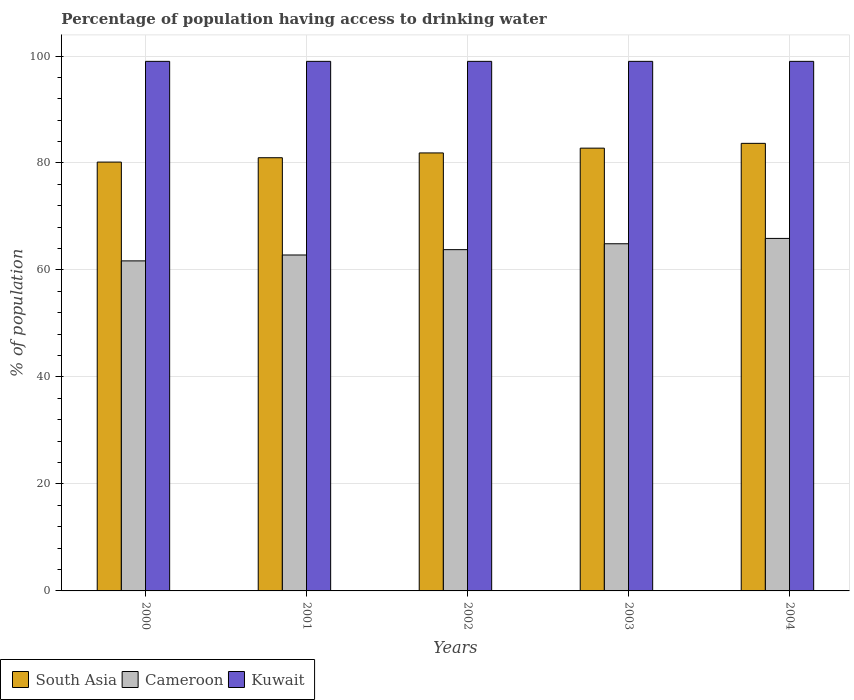How many different coloured bars are there?
Your answer should be compact. 3. Are the number of bars per tick equal to the number of legend labels?
Make the answer very short. Yes. How many bars are there on the 2nd tick from the left?
Your response must be concise. 3. How many bars are there on the 5th tick from the right?
Your response must be concise. 3. What is the percentage of population having access to drinking water in Kuwait in 2003?
Keep it short and to the point. 99. Across all years, what is the maximum percentage of population having access to drinking water in Cameroon?
Your answer should be very brief. 65.9. Across all years, what is the minimum percentage of population having access to drinking water in Kuwait?
Make the answer very short. 99. What is the total percentage of population having access to drinking water in South Asia in the graph?
Give a very brief answer. 409.48. What is the difference between the percentage of population having access to drinking water in Cameroon in 2000 and the percentage of population having access to drinking water in South Asia in 2003?
Give a very brief answer. -21.07. What is the average percentage of population having access to drinking water in Cameroon per year?
Offer a terse response. 63.82. In the year 2004, what is the difference between the percentage of population having access to drinking water in Kuwait and percentage of population having access to drinking water in South Asia?
Offer a very short reply. 15.33. What is the ratio of the percentage of population having access to drinking water in South Asia in 2002 to that in 2003?
Provide a succinct answer. 0.99. Is the percentage of population having access to drinking water in Cameroon in 2000 less than that in 2001?
Your answer should be compact. Yes. What is the difference between the highest and the second highest percentage of population having access to drinking water in Cameroon?
Give a very brief answer. 1. What is the difference between the highest and the lowest percentage of population having access to drinking water in Cameroon?
Offer a very short reply. 4.2. In how many years, is the percentage of population having access to drinking water in Kuwait greater than the average percentage of population having access to drinking water in Kuwait taken over all years?
Offer a terse response. 0. What does the 2nd bar from the left in 2003 represents?
Provide a short and direct response. Cameroon. What does the 1st bar from the right in 2003 represents?
Your answer should be very brief. Kuwait. What is the difference between two consecutive major ticks on the Y-axis?
Provide a succinct answer. 20. Are the values on the major ticks of Y-axis written in scientific E-notation?
Provide a succinct answer. No. Does the graph contain grids?
Provide a short and direct response. Yes. Where does the legend appear in the graph?
Offer a terse response. Bottom left. How are the legend labels stacked?
Ensure brevity in your answer.  Horizontal. What is the title of the graph?
Make the answer very short. Percentage of population having access to drinking water. Does "Sao Tome and Principe" appear as one of the legend labels in the graph?
Ensure brevity in your answer.  No. What is the label or title of the Y-axis?
Provide a succinct answer. % of population. What is the % of population in South Asia in 2000?
Give a very brief answer. 80.17. What is the % of population of Cameroon in 2000?
Provide a succinct answer. 61.7. What is the % of population of Kuwait in 2000?
Provide a succinct answer. 99. What is the % of population in South Asia in 2001?
Provide a short and direct response. 80.98. What is the % of population of Cameroon in 2001?
Make the answer very short. 62.8. What is the % of population in South Asia in 2002?
Give a very brief answer. 81.88. What is the % of population in Cameroon in 2002?
Make the answer very short. 63.8. What is the % of population of South Asia in 2003?
Provide a short and direct response. 82.77. What is the % of population of Cameroon in 2003?
Provide a short and direct response. 64.9. What is the % of population of South Asia in 2004?
Ensure brevity in your answer.  83.67. What is the % of population in Cameroon in 2004?
Your response must be concise. 65.9. Across all years, what is the maximum % of population in South Asia?
Make the answer very short. 83.67. Across all years, what is the maximum % of population in Cameroon?
Make the answer very short. 65.9. Across all years, what is the maximum % of population of Kuwait?
Ensure brevity in your answer.  99. Across all years, what is the minimum % of population in South Asia?
Your answer should be very brief. 80.17. Across all years, what is the minimum % of population in Cameroon?
Your answer should be compact. 61.7. Across all years, what is the minimum % of population in Kuwait?
Your answer should be compact. 99. What is the total % of population of South Asia in the graph?
Your answer should be very brief. 409.48. What is the total % of population of Cameroon in the graph?
Offer a terse response. 319.1. What is the total % of population of Kuwait in the graph?
Make the answer very short. 495. What is the difference between the % of population in South Asia in 2000 and that in 2001?
Provide a succinct answer. -0.81. What is the difference between the % of population in Kuwait in 2000 and that in 2001?
Give a very brief answer. 0. What is the difference between the % of population of South Asia in 2000 and that in 2002?
Your answer should be compact. -1.71. What is the difference between the % of population of Cameroon in 2000 and that in 2002?
Ensure brevity in your answer.  -2.1. What is the difference between the % of population of Kuwait in 2000 and that in 2002?
Your answer should be compact. 0. What is the difference between the % of population in South Asia in 2000 and that in 2003?
Offer a terse response. -2.61. What is the difference between the % of population of Kuwait in 2000 and that in 2003?
Your response must be concise. 0. What is the difference between the % of population in South Asia in 2000 and that in 2004?
Offer a terse response. -3.5. What is the difference between the % of population of Kuwait in 2000 and that in 2004?
Ensure brevity in your answer.  0. What is the difference between the % of population in South Asia in 2001 and that in 2002?
Provide a short and direct response. -0.9. What is the difference between the % of population of Cameroon in 2001 and that in 2002?
Make the answer very short. -1. What is the difference between the % of population of South Asia in 2001 and that in 2003?
Provide a succinct answer. -1.79. What is the difference between the % of population in Kuwait in 2001 and that in 2003?
Your answer should be very brief. 0. What is the difference between the % of population of South Asia in 2001 and that in 2004?
Your answer should be compact. -2.69. What is the difference between the % of population of Kuwait in 2001 and that in 2004?
Provide a short and direct response. 0. What is the difference between the % of population in South Asia in 2002 and that in 2003?
Your response must be concise. -0.89. What is the difference between the % of population in South Asia in 2002 and that in 2004?
Provide a succinct answer. -1.79. What is the difference between the % of population of Cameroon in 2002 and that in 2004?
Give a very brief answer. -2.1. What is the difference between the % of population in Kuwait in 2002 and that in 2004?
Ensure brevity in your answer.  0. What is the difference between the % of population in South Asia in 2003 and that in 2004?
Provide a short and direct response. -0.9. What is the difference between the % of population in Cameroon in 2003 and that in 2004?
Your answer should be very brief. -1. What is the difference between the % of population in Kuwait in 2003 and that in 2004?
Offer a terse response. 0. What is the difference between the % of population in South Asia in 2000 and the % of population in Cameroon in 2001?
Ensure brevity in your answer.  17.37. What is the difference between the % of population in South Asia in 2000 and the % of population in Kuwait in 2001?
Ensure brevity in your answer.  -18.83. What is the difference between the % of population of Cameroon in 2000 and the % of population of Kuwait in 2001?
Provide a short and direct response. -37.3. What is the difference between the % of population in South Asia in 2000 and the % of population in Cameroon in 2002?
Provide a succinct answer. 16.37. What is the difference between the % of population in South Asia in 2000 and the % of population in Kuwait in 2002?
Offer a very short reply. -18.83. What is the difference between the % of population of Cameroon in 2000 and the % of population of Kuwait in 2002?
Your answer should be very brief. -37.3. What is the difference between the % of population in South Asia in 2000 and the % of population in Cameroon in 2003?
Your answer should be compact. 15.27. What is the difference between the % of population in South Asia in 2000 and the % of population in Kuwait in 2003?
Your answer should be very brief. -18.83. What is the difference between the % of population of Cameroon in 2000 and the % of population of Kuwait in 2003?
Ensure brevity in your answer.  -37.3. What is the difference between the % of population in South Asia in 2000 and the % of population in Cameroon in 2004?
Make the answer very short. 14.27. What is the difference between the % of population of South Asia in 2000 and the % of population of Kuwait in 2004?
Offer a very short reply. -18.83. What is the difference between the % of population of Cameroon in 2000 and the % of population of Kuwait in 2004?
Give a very brief answer. -37.3. What is the difference between the % of population in South Asia in 2001 and the % of population in Cameroon in 2002?
Make the answer very short. 17.18. What is the difference between the % of population in South Asia in 2001 and the % of population in Kuwait in 2002?
Keep it short and to the point. -18.02. What is the difference between the % of population of Cameroon in 2001 and the % of population of Kuwait in 2002?
Your answer should be compact. -36.2. What is the difference between the % of population in South Asia in 2001 and the % of population in Cameroon in 2003?
Provide a succinct answer. 16.08. What is the difference between the % of population in South Asia in 2001 and the % of population in Kuwait in 2003?
Offer a very short reply. -18.02. What is the difference between the % of population of Cameroon in 2001 and the % of population of Kuwait in 2003?
Offer a very short reply. -36.2. What is the difference between the % of population of South Asia in 2001 and the % of population of Cameroon in 2004?
Give a very brief answer. 15.08. What is the difference between the % of population in South Asia in 2001 and the % of population in Kuwait in 2004?
Keep it short and to the point. -18.02. What is the difference between the % of population in Cameroon in 2001 and the % of population in Kuwait in 2004?
Make the answer very short. -36.2. What is the difference between the % of population in South Asia in 2002 and the % of population in Cameroon in 2003?
Your answer should be compact. 16.98. What is the difference between the % of population of South Asia in 2002 and the % of population of Kuwait in 2003?
Give a very brief answer. -17.12. What is the difference between the % of population of Cameroon in 2002 and the % of population of Kuwait in 2003?
Give a very brief answer. -35.2. What is the difference between the % of population in South Asia in 2002 and the % of population in Cameroon in 2004?
Your answer should be compact. 15.98. What is the difference between the % of population of South Asia in 2002 and the % of population of Kuwait in 2004?
Offer a very short reply. -17.12. What is the difference between the % of population in Cameroon in 2002 and the % of population in Kuwait in 2004?
Your response must be concise. -35.2. What is the difference between the % of population in South Asia in 2003 and the % of population in Cameroon in 2004?
Provide a short and direct response. 16.88. What is the difference between the % of population of South Asia in 2003 and the % of population of Kuwait in 2004?
Provide a succinct answer. -16.23. What is the difference between the % of population of Cameroon in 2003 and the % of population of Kuwait in 2004?
Your answer should be very brief. -34.1. What is the average % of population of South Asia per year?
Your answer should be compact. 81.9. What is the average % of population of Cameroon per year?
Provide a succinct answer. 63.82. In the year 2000, what is the difference between the % of population in South Asia and % of population in Cameroon?
Your answer should be very brief. 18.47. In the year 2000, what is the difference between the % of population of South Asia and % of population of Kuwait?
Your answer should be compact. -18.83. In the year 2000, what is the difference between the % of population in Cameroon and % of population in Kuwait?
Provide a short and direct response. -37.3. In the year 2001, what is the difference between the % of population in South Asia and % of population in Cameroon?
Offer a terse response. 18.18. In the year 2001, what is the difference between the % of population in South Asia and % of population in Kuwait?
Your answer should be compact. -18.02. In the year 2001, what is the difference between the % of population of Cameroon and % of population of Kuwait?
Provide a short and direct response. -36.2. In the year 2002, what is the difference between the % of population of South Asia and % of population of Cameroon?
Make the answer very short. 18.08. In the year 2002, what is the difference between the % of population of South Asia and % of population of Kuwait?
Make the answer very short. -17.12. In the year 2002, what is the difference between the % of population in Cameroon and % of population in Kuwait?
Provide a succinct answer. -35.2. In the year 2003, what is the difference between the % of population in South Asia and % of population in Cameroon?
Make the answer very short. 17.88. In the year 2003, what is the difference between the % of population in South Asia and % of population in Kuwait?
Your response must be concise. -16.23. In the year 2003, what is the difference between the % of population in Cameroon and % of population in Kuwait?
Make the answer very short. -34.1. In the year 2004, what is the difference between the % of population in South Asia and % of population in Cameroon?
Ensure brevity in your answer.  17.77. In the year 2004, what is the difference between the % of population in South Asia and % of population in Kuwait?
Give a very brief answer. -15.33. In the year 2004, what is the difference between the % of population in Cameroon and % of population in Kuwait?
Your answer should be compact. -33.1. What is the ratio of the % of population of Cameroon in 2000 to that in 2001?
Give a very brief answer. 0.98. What is the ratio of the % of population in Kuwait in 2000 to that in 2001?
Provide a short and direct response. 1. What is the ratio of the % of population of South Asia in 2000 to that in 2002?
Your answer should be very brief. 0.98. What is the ratio of the % of population of Cameroon in 2000 to that in 2002?
Keep it short and to the point. 0.97. What is the ratio of the % of population in South Asia in 2000 to that in 2003?
Offer a very short reply. 0.97. What is the ratio of the % of population in Cameroon in 2000 to that in 2003?
Offer a terse response. 0.95. What is the ratio of the % of population in Kuwait in 2000 to that in 2003?
Your answer should be compact. 1. What is the ratio of the % of population in South Asia in 2000 to that in 2004?
Give a very brief answer. 0.96. What is the ratio of the % of population of Cameroon in 2000 to that in 2004?
Give a very brief answer. 0.94. What is the ratio of the % of population of Kuwait in 2000 to that in 2004?
Your answer should be very brief. 1. What is the ratio of the % of population of Cameroon in 2001 to that in 2002?
Offer a very short reply. 0.98. What is the ratio of the % of population of South Asia in 2001 to that in 2003?
Keep it short and to the point. 0.98. What is the ratio of the % of population of Cameroon in 2001 to that in 2003?
Keep it short and to the point. 0.97. What is the ratio of the % of population of South Asia in 2001 to that in 2004?
Ensure brevity in your answer.  0.97. What is the ratio of the % of population in Cameroon in 2001 to that in 2004?
Offer a terse response. 0.95. What is the ratio of the % of population of Cameroon in 2002 to that in 2003?
Your answer should be compact. 0.98. What is the ratio of the % of population in South Asia in 2002 to that in 2004?
Your answer should be very brief. 0.98. What is the ratio of the % of population of Cameroon in 2002 to that in 2004?
Give a very brief answer. 0.97. What is the ratio of the % of population in Kuwait in 2002 to that in 2004?
Ensure brevity in your answer.  1. What is the ratio of the % of population in South Asia in 2003 to that in 2004?
Offer a very short reply. 0.99. What is the ratio of the % of population of Cameroon in 2003 to that in 2004?
Provide a succinct answer. 0.98. What is the ratio of the % of population in Kuwait in 2003 to that in 2004?
Ensure brevity in your answer.  1. What is the difference between the highest and the second highest % of population of South Asia?
Give a very brief answer. 0.9. What is the difference between the highest and the second highest % of population of Cameroon?
Make the answer very short. 1. What is the difference between the highest and the lowest % of population in South Asia?
Provide a short and direct response. 3.5. 